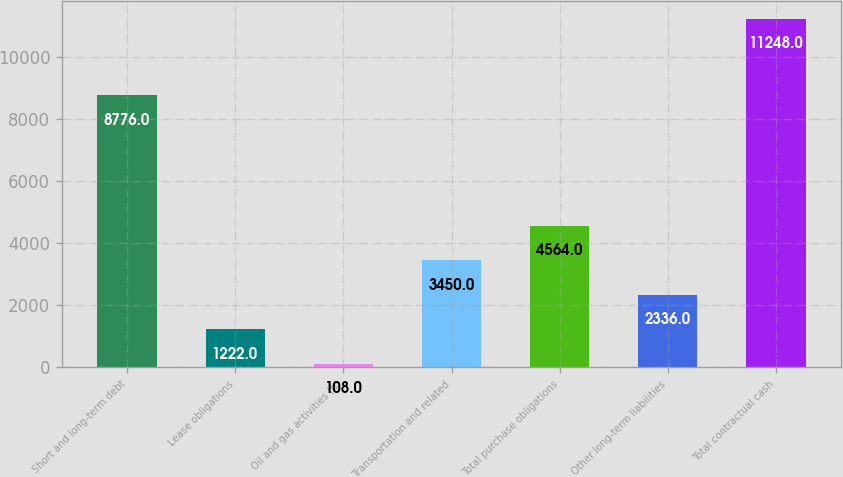<chart> <loc_0><loc_0><loc_500><loc_500><bar_chart><fcel>Short and long-term debt<fcel>Lease obligations<fcel>Oil and gas activities (b)<fcel>Transportation and related<fcel>Total purchase obligations<fcel>Other long-term liabilities<fcel>Total contractual cash<nl><fcel>8776<fcel>1222<fcel>108<fcel>3450<fcel>4564<fcel>2336<fcel>11248<nl></chart> 